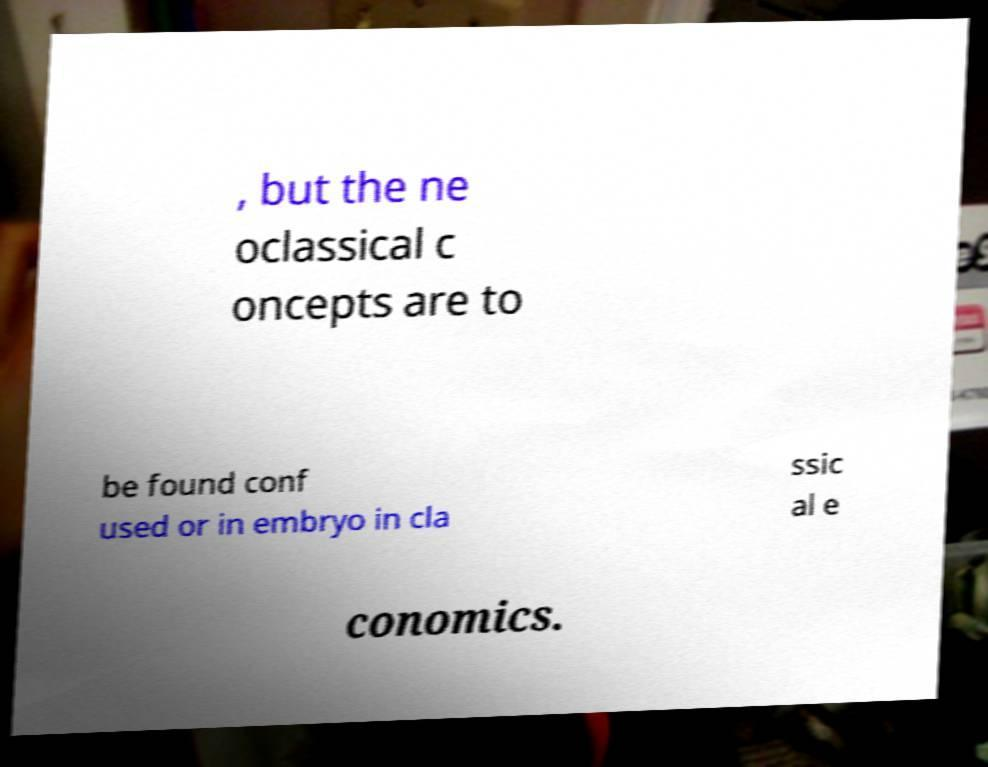Please identify and transcribe the text found in this image. , but the ne oclassical c oncepts are to be found conf used or in embryo in cla ssic al e conomics. 